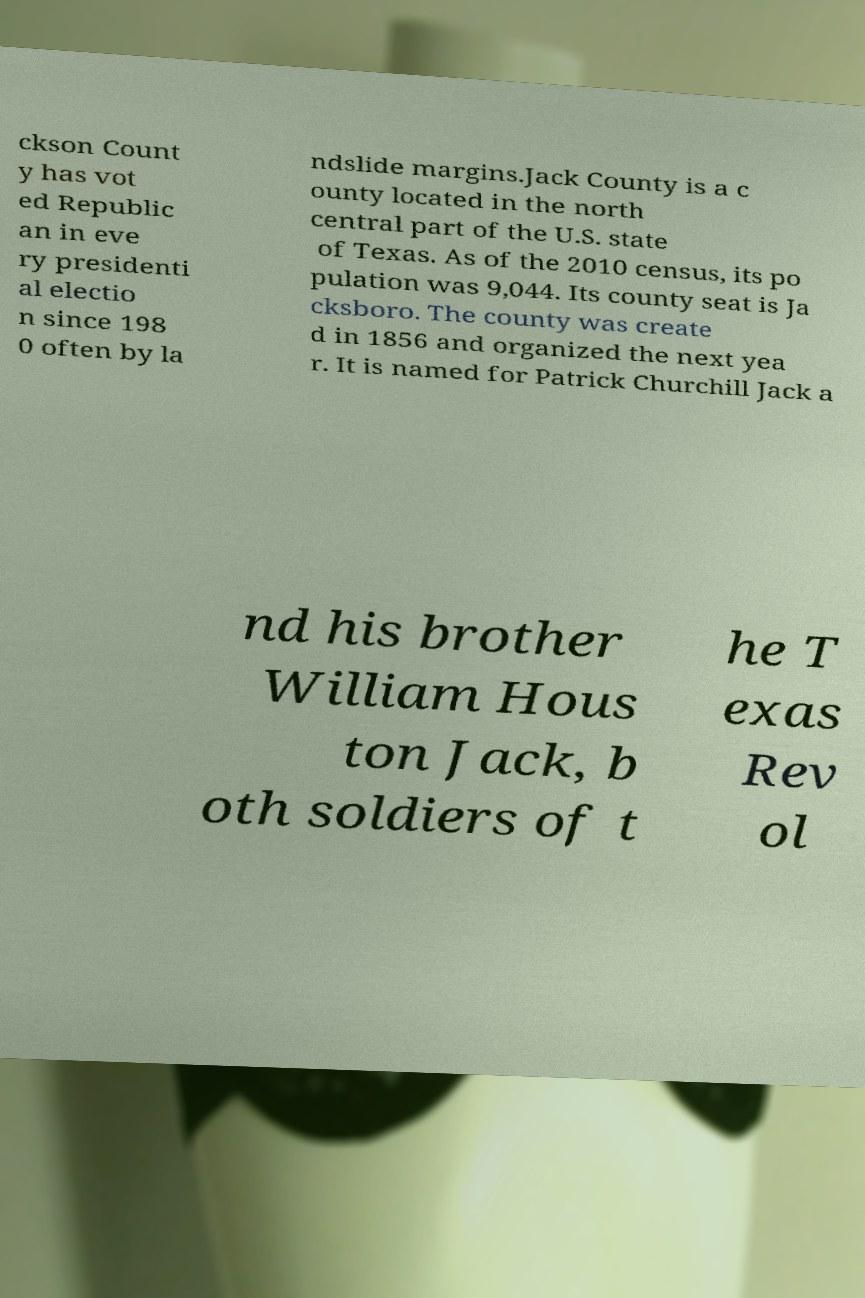I need the written content from this picture converted into text. Can you do that? ckson Count y has vot ed Republic an in eve ry presidenti al electio n since 198 0 often by la ndslide margins.Jack County is a c ounty located in the north central part of the U.S. state of Texas. As of the 2010 census, its po pulation was 9,044. Its county seat is Ja cksboro. The county was create d in 1856 and organized the next yea r. It is named for Patrick Churchill Jack a nd his brother William Hous ton Jack, b oth soldiers of t he T exas Rev ol 